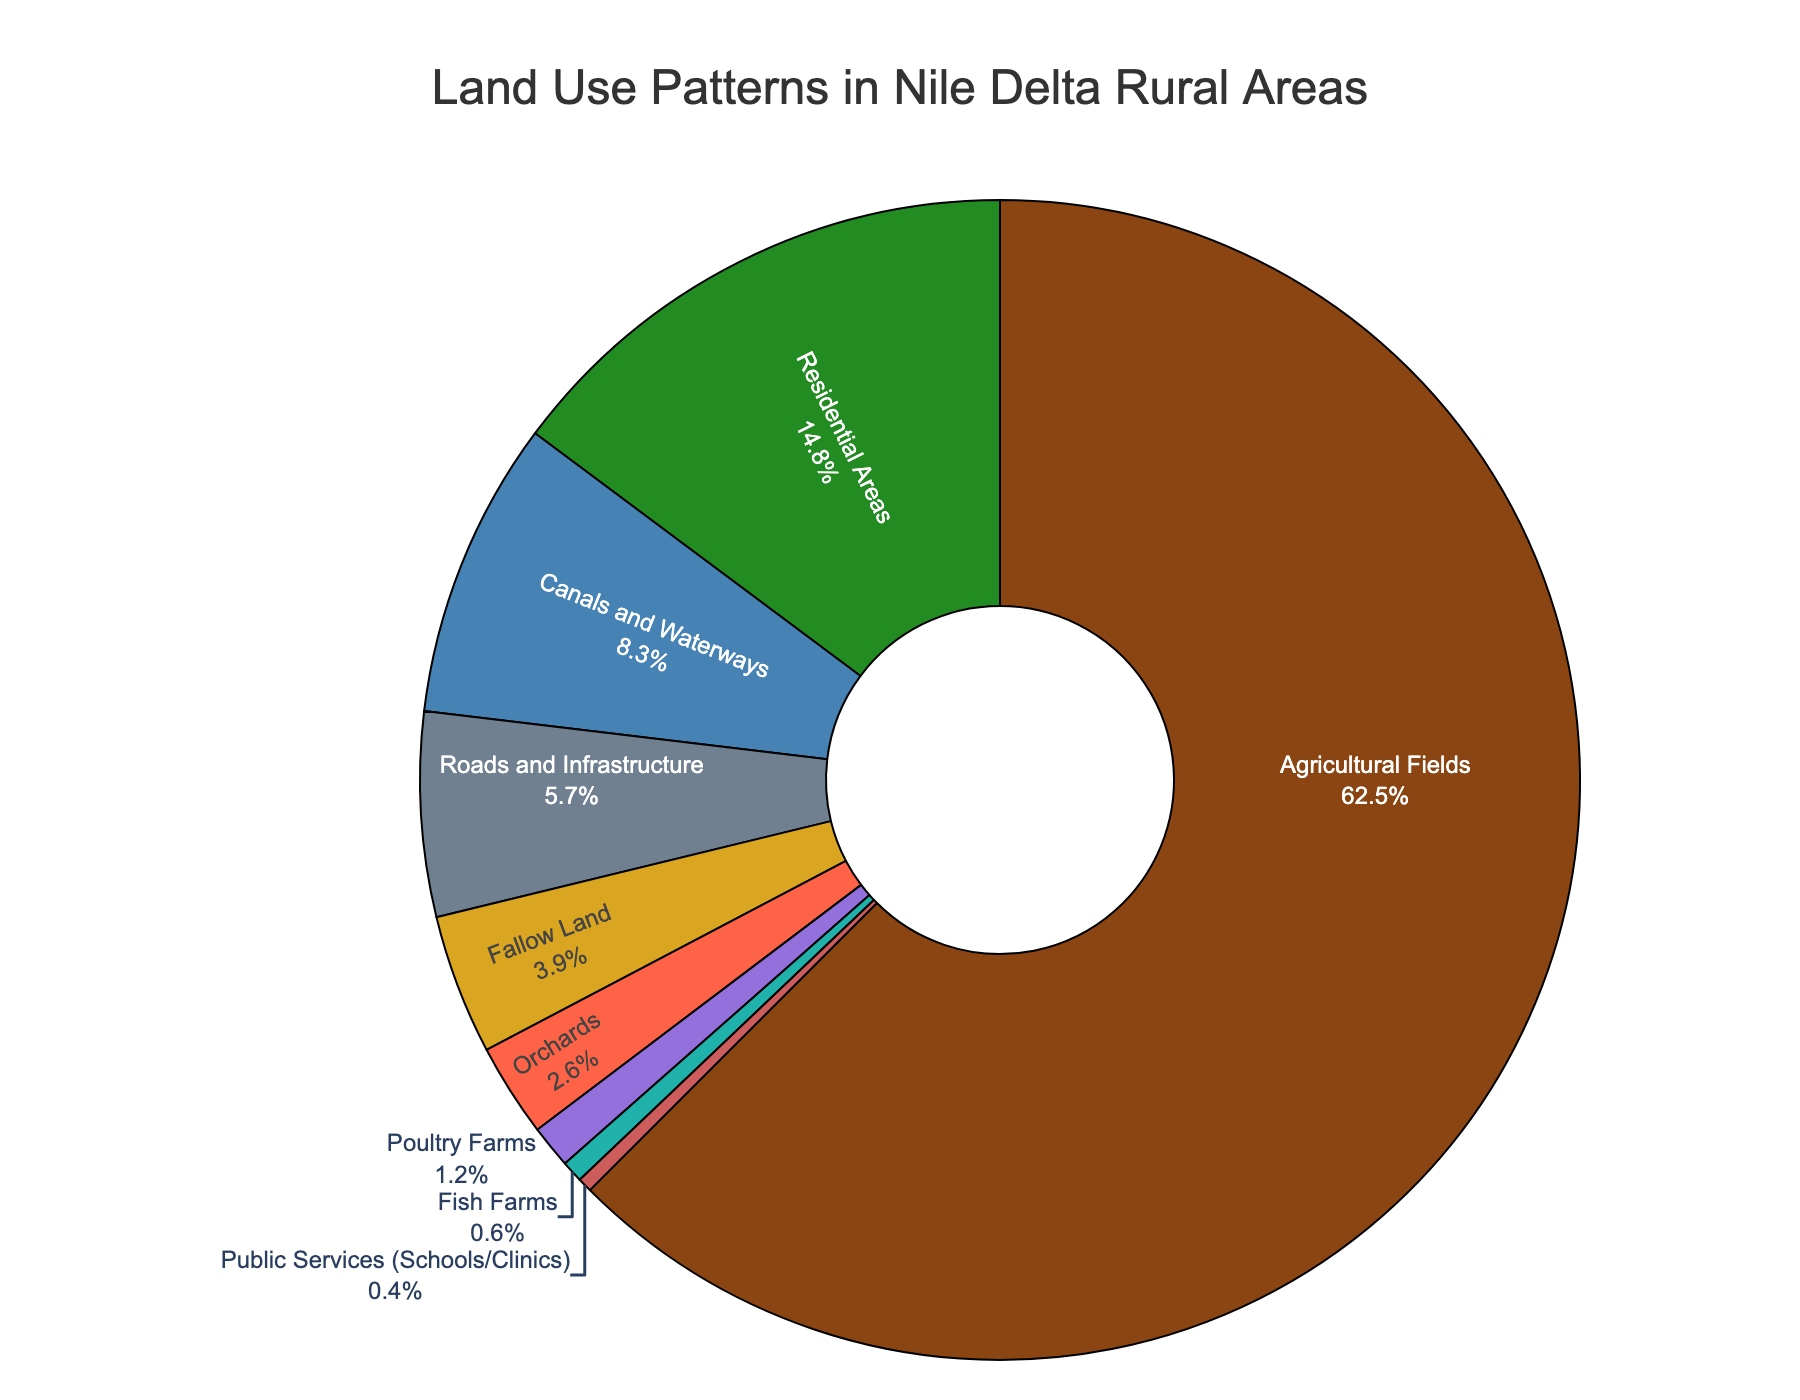What percentage of land is used for agricultural fields? The agricultural fields' slice represents 62.5% of the chart, which is shown directly on the figure.
Answer: 62.5% Which land use type has a higher percentage, residential areas or fallow land? The percentage for residential areas is 14.8%, while for fallow land it is 3.9%. Since 14.8% is higher than 3.9%, residential areas have a higher land use percentage.
Answer: Residential Areas What is the combined percentage of land used for fish farms and poultry farms? The percentage for fish farms is 0.6%, and for poultry farms, it is 1.2%. Adding these together, 0.6 + 1.2 = 1.8%.
Answer: 1.8% Which land use type occupies the least amount of land? Among the given categories, public services (schools/clinics) have the smallest slice, which is 0.4%.
Answer: Public Services How much more land is used for roads and infrastructure compared to canals and waterways? The percentage for roads and infrastructure is 5.7%, and for canals and waterways, it is 8.3%. Subtracting these, 8.3% - 5.7% = 2.6%.
Answer: 2.6% What percentage of land is dedicated to non-agricultural uses (all uses except agricultural fields)? Agricultural fields use 62.5% of the land. Therefore, the non-agricultural uses percentage is 100% - 62.5% = 37.5%.
Answer: 37.5% Are more than 5% of the land used for orchards and poultry farms combined? Orchards use 2.6% of the land and poultry farms use 1.2%. Adding these, 2.6 + 1.2 = 3.8%, which is less than 5%.
Answer: No Which has a greater percentage of land use, orchards or fish farms? Orchards occupy 2.6% of the land, whereas fish farms occupy 0.6%. Since 2.6% is greater than 0.6%, orchards use more land.
Answer: Orchards How does the land use for fallow land compare visually to canals and waterways? Fallow land (3.9%) has a smaller slice compared to canals and waterways (8.3%) as indicated by their respective segments in the pie chart.
Answer: Smaller What is the difference between the land used for poultry farms and public services? Poultry farms use 1.2% of the land, while public services use 0.4%. The difference is 1.2% - 0.4% = 0.8%.
Answer: 0.8% 